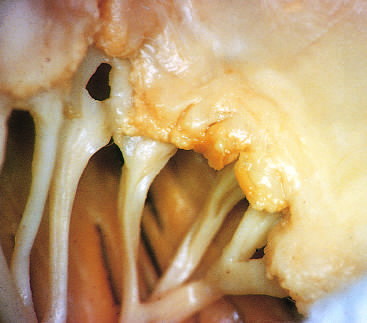have previous episodes of rheumatic valvulitis caused fibrous thickening and fusion of the chordae tendineae?
Answer the question using a single word or phrase. Yes 